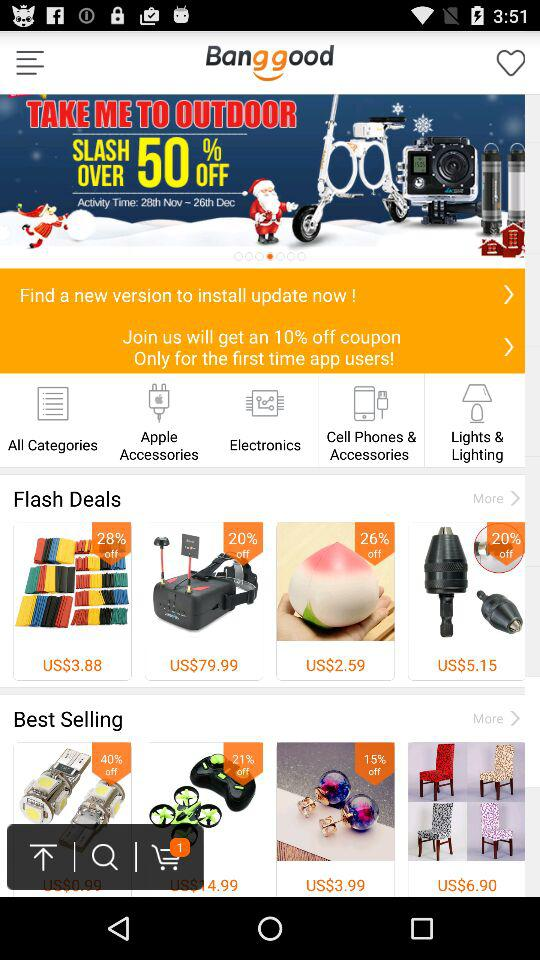What is the discount on smart devices? The discount on smart devices is more than 50% off. 